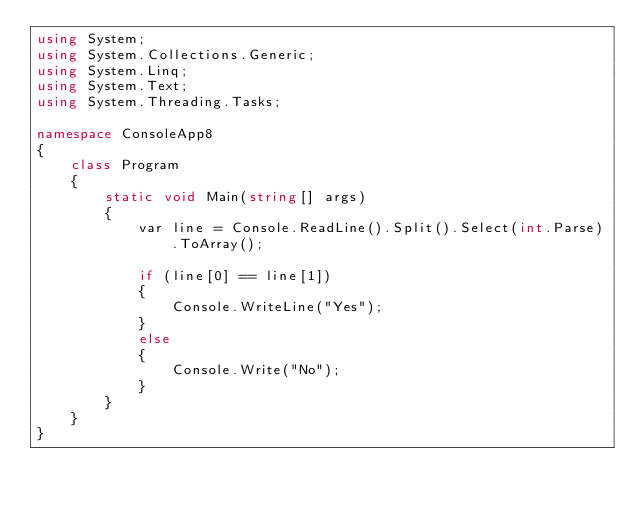<code> <loc_0><loc_0><loc_500><loc_500><_C#_>using System;
using System.Collections.Generic;
using System.Linq;
using System.Text;
using System.Threading.Tasks;

namespace ConsoleApp8
{
    class Program
    {
        static void Main(string[] args)
        {
            var line = Console.ReadLine().Split().Select(int.Parse).ToArray();

            if (line[0] == line[1])
            {
                Console.WriteLine("Yes");
            }
            else
            {
                Console.Write("No");
            }
        }
    }
}
</code> 